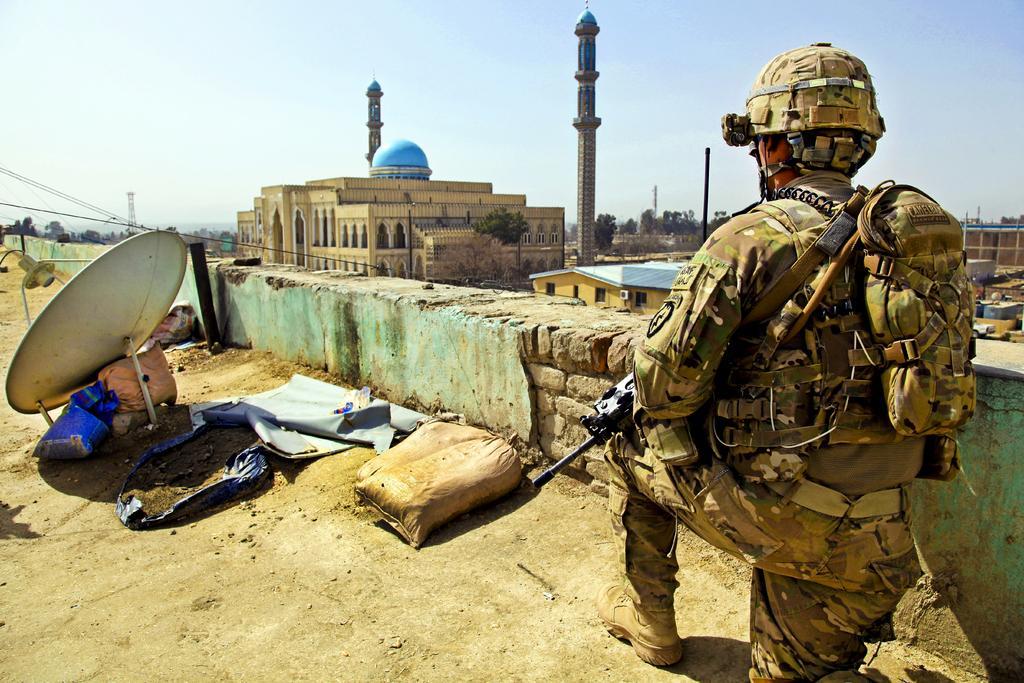Describe this image in one or two sentences. In this image in the right a person is kneeling down. He is wearing army uniform. He is holding a gun and carrying a bag. On the floor there are sacs, antenna, and few other things. In the background there are buildings, towers, trees. The sky is clear. 